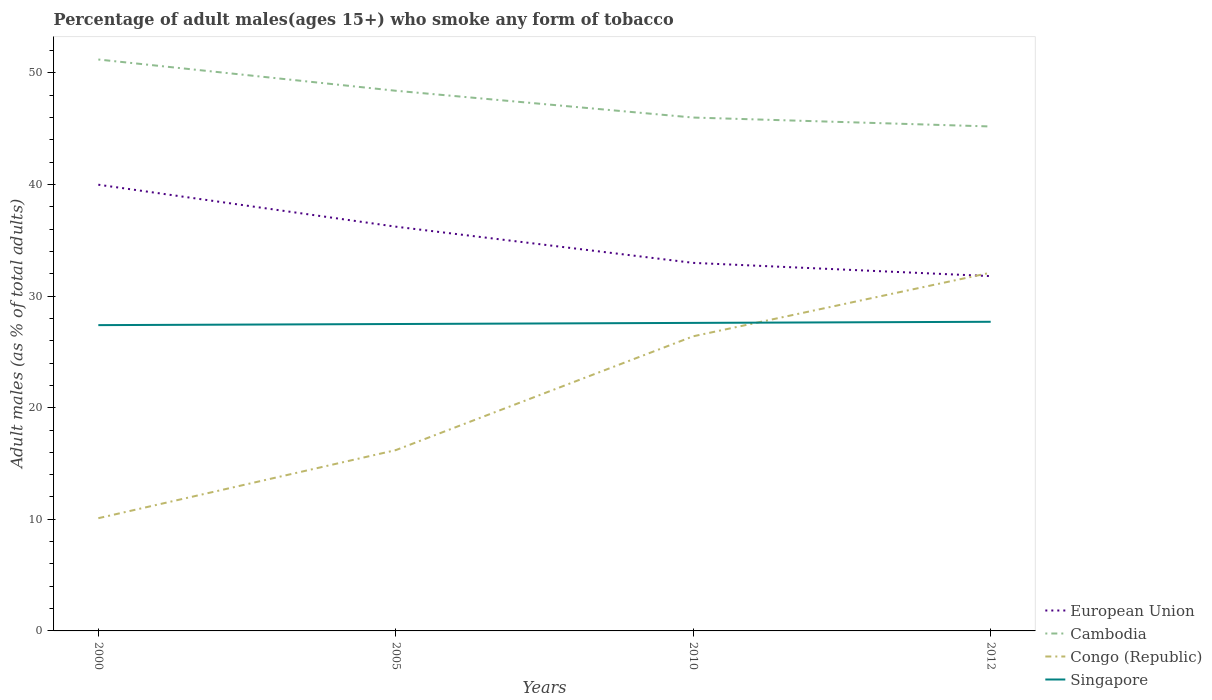Does the line corresponding to Cambodia intersect with the line corresponding to Singapore?
Your response must be concise. No. Across all years, what is the maximum percentage of adult males who smoke in Singapore?
Keep it short and to the point. 27.4. What is the total percentage of adult males who smoke in Congo (Republic) in the graph?
Give a very brief answer. -22. What is the difference between the highest and the second highest percentage of adult males who smoke in European Union?
Make the answer very short. 8.19. What is the difference between the highest and the lowest percentage of adult males who smoke in Congo (Republic)?
Keep it short and to the point. 2. How many legend labels are there?
Ensure brevity in your answer.  4. What is the title of the graph?
Provide a short and direct response. Percentage of adult males(ages 15+) who smoke any form of tobacco. What is the label or title of the Y-axis?
Ensure brevity in your answer.  Adult males (as % of total adults). What is the Adult males (as % of total adults) in European Union in 2000?
Provide a succinct answer. 39.98. What is the Adult males (as % of total adults) in Cambodia in 2000?
Keep it short and to the point. 51.2. What is the Adult males (as % of total adults) in Congo (Republic) in 2000?
Offer a terse response. 10.1. What is the Adult males (as % of total adults) of Singapore in 2000?
Ensure brevity in your answer.  27.4. What is the Adult males (as % of total adults) of European Union in 2005?
Provide a short and direct response. 36.22. What is the Adult males (as % of total adults) in Cambodia in 2005?
Provide a short and direct response. 48.4. What is the Adult males (as % of total adults) in Congo (Republic) in 2005?
Your response must be concise. 16.2. What is the Adult males (as % of total adults) of European Union in 2010?
Provide a short and direct response. 32.98. What is the Adult males (as % of total adults) of Congo (Republic) in 2010?
Your answer should be very brief. 26.4. What is the Adult males (as % of total adults) of Singapore in 2010?
Offer a terse response. 27.6. What is the Adult males (as % of total adults) of European Union in 2012?
Provide a succinct answer. 31.79. What is the Adult males (as % of total adults) in Cambodia in 2012?
Your answer should be very brief. 45.2. What is the Adult males (as % of total adults) in Congo (Republic) in 2012?
Provide a short and direct response. 32.1. What is the Adult males (as % of total adults) of Singapore in 2012?
Make the answer very short. 27.7. Across all years, what is the maximum Adult males (as % of total adults) of European Union?
Provide a succinct answer. 39.98. Across all years, what is the maximum Adult males (as % of total adults) of Cambodia?
Offer a very short reply. 51.2. Across all years, what is the maximum Adult males (as % of total adults) in Congo (Republic)?
Keep it short and to the point. 32.1. Across all years, what is the maximum Adult males (as % of total adults) in Singapore?
Your answer should be compact. 27.7. Across all years, what is the minimum Adult males (as % of total adults) of European Union?
Keep it short and to the point. 31.79. Across all years, what is the minimum Adult males (as % of total adults) of Cambodia?
Give a very brief answer. 45.2. Across all years, what is the minimum Adult males (as % of total adults) of Singapore?
Your answer should be compact. 27.4. What is the total Adult males (as % of total adults) of European Union in the graph?
Your response must be concise. 140.97. What is the total Adult males (as % of total adults) of Cambodia in the graph?
Offer a very short reply. 190.8. What is the total Adult males (as % of total adults) in Congo (Republic) in the graph?
Ensure brevity in your answer.  84.8. What is the total Adult males (as % of total adults) in Singapore in the graph?
Make the answer very short. 110.2. What is the difference between the Adult males (as % of total adults) in European Union in 2000 and that in 2005?
Ensure brevity in your answer.  3.76. What is the difference between the Adult males (as % of total adults) of Cambodia in 2000 and that in 2005?
Your response must be concise. 2.8. What is the difference between the Adult males (as % of total adults) of Singapore in 2000 and that in 2005?
Provide a succinct answer. -0.1. What is the difference between the Adult males (as % of total adults) in European Union in 2000 and that in 2010?
Keep it short and to the point. 7. What is the difference between the Adult males (as % of total adults) in Congo (Republic) in 2000 and that in 2010?
Your answer should be compact. -16.3. What is the difference between the Adult males (as % of total adults) of European Union in 2000 and that in 2012?
Make the answer very short. 8.19. What is the difference between the Adult males (as % of total adults) in Singapore in 2000 and that in 2012?
Offer a very short reply. -0.3. What is the difference between the Adult males (as % of total adults) of European Union in 2005 and that in 2010?
Provide a short and direct response. 3.24. What is the difference between the Adult males (as % of total adults) of Singapore in 2005 and that in 2010?
Your answer should be compact. -0.1. What is the difference between the Adult males (as % of total adults) of European Union in 2005 and that in 2012?
Your response must be concise. 4.43. What is the difference between the Adult males (as % of total adults) of Cambodia in 2005 and that in 2012?
Provide a succinct answer. 3.2. What is the difference between the Adult males (as % of total adults) of Congo (Republic) in 2005 and that in 2012?
Keep it short and to the point. -15.9. What is the difference between the Adult males (as % of total adults) in European Union in 2010 and that in 2012?
Give a very brief answer. 1.19. What is the difference between the Adult males (as % of total adults) of Congo (Republic) in 2010 and that in 2012?
Offer a very short reply. -5.7. What is the difference between the Adult males (as % of total adults) in Singapore in 2010 and that in 2012?
Offer a terse response. -0.1. What is the difference between the Adult males (as % of total adults) in European Union in 2000 and the Adult males (as % of total adults) in Cambodia in 2005?
Your response must be concise. -8.42. What is the difference between the Adult males (as % of total adults) of European Union in 2000 and the Adult males (as % of total adults) of Congo (Republic) in 2005?
Make the answer very short. 23.78. What is the difference between the Adult males (as % of total adults) of European Union in 2000 and the Adult males (as % of total adults) of Singapore in 2005?
Ensure brevity in your answer.  12.48. What is the difference between the Adult males (as % of total adults) in Cambodia in 2000 and the Adult males (as % of total adults) in Congo (Republic) in 2005?
Your answer should be very brief. 35. What is the difference between the Adult males (as % of total adults) in Cambodia in 2000 and the Adult males (as % of total adults) in Singapore in 2005?
Make the answer very short. 23.7. What is the difference between the Adult males (as % of total adults) of Congo (Republic) in 2000 and the Adult males (as % of total adults) of Singapore in 2005?
Make the answer very short. -17.4. What is the difference between the Adult males (as % of total adults) of European Union in 2000 and the Adult males (as % of total adults) of Cambodia in 2010?
Give a very brief answer. -6.02. What is the difference between the Adult males (as % of total adults) in European Union in 2000 and the Adult males (as % of total adults) in Congo (Republic) in 2010?
Provide a short and direct response. 13.58. What is the difference between the Adult males (as % of total adults) in European Union in 2000 and the Adult males (as % of total adults) in Singapore in 2010?
Your answer should be compact. 12.38. What is the difference between the Adult males (as % of total adults) in Cambodia in 2000 and the Adult males (as % of total adults) in Congo (Republic) in 2010?
Your answer should be very brief. 24.8. What is the difference between the Adult males (as % of total adults) in Cambodia in 2000 and the Adult males (as % of total adults) in Singapore in 2010?
Keep it short and to the point. 23.6. What is the difference between the Adult males (as % of total adults) in Congo (Republic) in 2000 and the Adult males (as % of total adults) in Singapore in 2010?
Make the answer very short. -17.5. What is the difference between the Adult males (as % of total adults) in European Union in 2000 and the Adult males (as % of total adults) in Cambodia in 2012?
Ensure brevity in your answer.  -5.22. What is the difference between the Adult males (as % of total adults) of European Union in 2000 and the Adult males (as % of total adults) of Congo (Republic) in 2012?
Your answer should be compact. 7.88. What is the difference between the Adult males (as % of total adults) of European Union in 2000 and the Adult males (as % of total adults) of Singapore in 2012?
Your answer should be compact. 12.28. What is the difference between the Adult males (as % of total adults) of Cambodia in 2000 and the Adult males (as % of total adults) of Congo (Republic) in 2012?
Provide a short and direct response. 19.1. What is the difference between the Adult males (as % of total adults) in Congo (Republic) in 2000 and the Adult males (as % of total adults) in Singapore in 2012?
Your response must be concise. -17.6. What is the difference between the Adult males (as % of total adults) in European Union in 2005 and the Adult males (as % of total adults) in Cambodia in 2010?
Your answer should be compact. -9.78. What is the difference between the Adult males (as % of total adults) of European Union in 2005 and the Adult males (as % of total adults) of Congo (Republic) in 2010?
Provide a succinct answer. 9.82. What is the difference between the Adult males (as % of total adults) of European Union in 2005 and the Adult males (as % of total adults) of Singapore in 2010?
Your answer should be compact. 8.62. What is the difference between the Adult males (as % of total adults) in Cambodia in 2005 and the Adult males (as % of total adults) in Singapore in 2010?
Offer a very short reply. 20.8. What is the difference between the Adult males (as % of total adults) in Congo (Republic) in 2005 and the Adult males (as % of total adults) in Singapore in 2010?
Provide a succinct answer. -11.4. What is the difference between the Adult males (as % of total adults) in European Union in 2005 and the Adult males (as % of total adults) in Cambodia in 2012?
Provide a short and direct response. -8.98. What is the difference between the Adult males (as % of total adults) in European Union in 2005 and the Adult males (as % of total adults) in Congo (Republic) in 2012?
Ensure brevity in your answer.  4.12. What is the difference between the Adult males (as % of total adults) in European Union in 2005 and the Adult males (as % of total adults) in Singapore in 2012?
Your answer should be very brief. 8.52. What is the difference between the Adult males (as % of total adults) in Cambodia in 2005 and the Adult males (as % of total adults) in Congo (Republic) in 2012?
Ensure brevity in your answer.  16.3. What is the difference between the Adult males (as % of total adults) in Cambodia in 2005 and the Adult males (as % of total adults) in Singapore in 2012?
Provide a succinct answer. 20.7. What is the difference between the Adult males (as % of total adults) of Congo (Republic) in 2005 and the Adult males (as % of total adults) of Singapore in 2012?
Ensure brevity in your answer.  -11.5. What is the difference between the Adult males (as % of total adults) in European Union in 2010 and the Adult males (as % of total adults) in Cambodia in 2012?
Ensure brevity in your answer.  -12.22. What is the difference between the Adult males (as % of total adults) in European Union in 2010 and the Adult males (as % of total adults) in Congo (Republic) in 2012?
Give a very brief answer. 0.88. What is the difference between the Adult males (as % of total adults) in European Union in 2010 and the Adult males (as % of total adults) in Singapore in 2012?
Your answer should be very brief. 5.28. What is the difference between the Adult males (as % of total adults) in Congo (Republic) in 2010 and the Adult males (as % of total adults) in Singapore in 2012?
Give a very brief answer. -1.3. What is the average Adult males (as % of total adults) in European Union per year?
Your answer should be compact. 35.24. What is the average Adult males (as % of total adults) of Cambodia per year?
Ensure brevity in your answer.  47.7. What is the average Adult males (as % of total adults) in Congo (Republic) per year?
Offer a very short reply. 21.2. What is the average Adult males (as % of total adults) in Singapore per year?
Offer a very short reply. 27.55. In the year 2000, what is the difference between the Adult males (as % of total adults) in European Union and Adult males (as % of total adults) in Cambodia?
Offer a terse response. -11.22. In the year 2000, what is the difference between the Adult males (as % of total adults) in European Union and Adult males (as % of total adults) in Congo (Republic)?
Keep it short and to the point. 29.88. In the year 2000, what is the difference between the Adult males (as % of total adults) of European Union and Adult males (as % of total adults) of Singapore?
Provide a short and direct response. 12.58. In the year 2000, what is the difference between the Adult males (as % of total adults) of Cambodia and Adult males (as % of total adults) of Congo (Republic)?
Your answer should be very brief. 41.1. In the year 2000, what is the difference between the Adult males (as % of total adults) in Cambodia and Adult males (as % of total adults) in Singapore?
Your response must be concise. 23.8. In the year 2000, what is the difference between the Adult males (as % of total adults) in Congo (Republic) and Adult males (as % of total adults) in Singapore?
Your response must be concise. -17.3. In the year 2005, what is the difference between the Adult males (as % of total adults) of European Union and Adult males (as % of total adults) of Cambodia?
Your answer should be very brief. -12.18. In the year 2005, what is the difference between the Adult males (as % of total adults) of European Union and Adult males (as % of total adults) of Congo (Republic)?
Ensure brevity in your answer.  20.02. In the year 2005, what is the difference between the Adult males (as % of total adults) of European Union and Adult males (as % of total adults) of Singapore?
Provide a succinct answer. 8.72. In the year 2005, what is the difference between the Adult males (as % of total adults) in Cambodia and Adult males (as % of total adults) in Congo (Republic)?
Keep it short and to the point. 32.2. In the year 2005, what is the difference between the Adult males (as % of total adults) in Cambodia and Adult males (as % of total adults) in Singapore?
Give a very brief answer. 20.9. In the year 2005, what is the difference between the Adult males (as % of total adults) of Congo (Republic) and Adult males (as % of total adults) of Singapore?
Provide a short and direct response. -11.3. In the year 2010, what is the difference between the Adult males (as % of total adults) of European Union and Adult males (as % of total adults) of Cambodia?
Provide a succinct answer. -13.02. In the year 2010, what is the difference between the Adult males (as % of total adults) in European Union and Adult males (as % of total adults) in Congo (Republic)?
Ensure brevity in your answer.  6.58. In the year 2010, what is the difference between the Adult males (as % of total adults) in European Union and Adult males (as % of total adults) in Singapore?
Keep it short and to the point. 5.38. In the year 2010, what is the difference between the Adult males (as % of total adults) of Cambodia and Adult males (as % of total adults) of Congo (Republic)?
Your answer should be compact. 19.6. In the year 2010, what is the difference between the Adult males (as % of total adults) in Cambodia and Adult males (as % of total adults) in Singapore?
Ensure brevity in your answer.  18.4. In the year 2010, what is the difference between the Adult males (as % of total adults) of Congo (Republic) and Adult males (as % of total adults) of Singapore?
Provide a short and direct response. -1.2. In the year 2012, what is the difference between the Adult males (as % of total adults) of European Union and Adult males (as % of total adults) of Cambodia?
Your response must be concise. -13.41. In the year 2012, what is the difference between the Adult males (as % of total adults) in European Union and Adult males (as % of total adults) in Congo (Republic)?
Offer a very short reply. -0.31. In the year 2012, what is the difference between the Adult males (as % of total adults) in European Union and Adult males (as % of total adults) in Singapore?
Your response must be concise. 4.09. In the year 2012, what is the difference between the Adult males (as % of total adults) in Cambodia and Adult males (as % of total adults) in Congo (Republic)?
Make the answer very short. 13.1. In the year 2012, what is the difference between the Adult males (as % of total adults) in Congo (Republic) and Adult males (as % of total adults) in Singapore?
Make the answer very short. 4.4. What is the ratio of the Adult males (as % of total adults) in European Union in 2000 to that in 2005?
Keep it short and to the point. 1.1. What is the ratio of the Adult males (as % of total adults) in Cambodia in 2000 to that in 2005?
Make the answer very short. 1.06. What is the ratio of the Adult males (as % of total adults) in Congo (Republic) in 2000 to that in 2005?
Offer a very short reply. 0.62. What is the ratio of the Adult males (as % of total adults) in European Union in 2000 to that in 2010?
Your answer should be very brief. 1.21. What is the ratio of the Adult males (as % of total adults) of Cambodia in 2000 to that in 2010?
Provide a succinct answer. 1.11. What is the ratio of the Adult males (as % of total adults) of Congo (Republic) in 2000 to that in 2010?
Offer a terse response. 0.38. What is the ratio of the Adult males (as % of total adults) in European Union in 2000 to that in 2012?
Make the answer very short. 1.26. What is the ratio of the Adult males (as % of total adults) in Cambodia in 2000 to that in 2012?
Your answer should be compact. 1.13. What is the ratio of the Adult males (as % of total adults) in Congo (Republic) in 2000 to that in 2012?
Provide a short and direct response. 0.31. What is the ratio of the Adult males (as % of total adults) in Singapore in 2000 to that in 2012?
Your answer should be compact. 0.99. What is the ratio of the Adult males (as % of total adults) in European Union in 2005 to that in 2010?
Give a very brief answer. 1.1. What is the ratio of the Adult males (as % of total adults) in Cambodia in 2005 to that in 2010?
Ensure brevity in your answer.  1.05. What is the ratio of the Adult males (as % of total adults) in Congo (Republic) in 2005 to that in 2010?
Keep it short and to the point. 0.61. What is the ratio of the Adult males (as % of total adults) of European Union in 2005 to that in 2012?
Give a very brief answer. 1.14. What is the ratio of the Adult males (as % of total adults) in Cambodia in 2005 to that in 2012?
Keep it short and to the point. 1.07. What is the ratio of the Adult males (as % of total adults) of Congo (Republic) in 2005 to that in 2012?
Provide a short and direct response. 0.5. What is the ratio of the Adult males (as % of total adults) in European Union in 2010 to that in 2012?
Offer a very short reply. 1.04. What is the ratio of the Adult males (as % of total adults) of Cambodia in 2010 to that in 2012?
Offer a terse response. 1.02. What is the ratio of the Adult males (as % of total adults) in Congo (Republic) in 2010 to that in 2012?
Offer a terse response. 0.82. What is the difference between the highest and the second highest Adult males (as % of total adults) in European Union?
Your response must be concise. 3.76. What is the difference between the highest and the lowest Adult males (as % of total adults) of European Union?
Provide a short and direct response. 8.19. What is the difference between the highest and the lowest Adult males (as % of total adults) in Cambodia?
Your response must be concise. 6. What is the difference between the highest and the lowest Adult males (as % of total adults) in Congo (Republic)?
Offer a terse response. 22. What is the difference between the highest and the lowest Adult males (as % of total adults) in Singapore?
Offer a terse response. 0.3. 